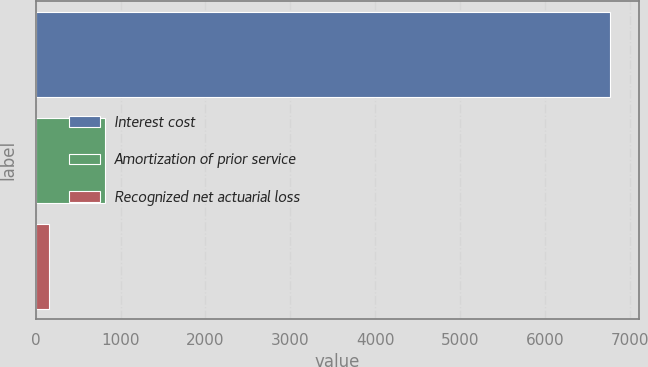Convert chart. <chart><loc_0><loc_0><loc_500><loc_500><bar_chart><fcel>Interest cost<fcel>Amortization of prior service<fcel>Recognized net actuarial loss<nl><fcel>6772<fcel>819.4<fcel>158<nl></chart> 